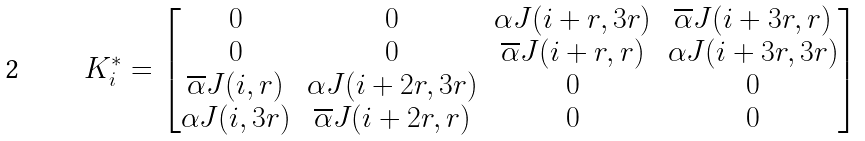<formula> <loc_0><loc_0><loc_500><loc_500>K ^ { * } _ { i } = \begin{bmatrix} 0 & 0 & \alpha J ( i + r , 3 r ) & \overline { \alpha } J ( i + 3 r , r ) \\ 0 & 0 & \overline { \alpha } J ( i + r , r ) & \alpha J ( i + 3 r , 3 r ) \\ \overline { \alpha } J ( i , r ) & \alpha J ( i + 2 r , 3 r ) & 0 & 0 \\ \alpha J ( i , 3 r ) & \overline { \alpha } J ( i + 2 r , r ) & 0 & 0 \\ \end{bmatrix}</formula> 